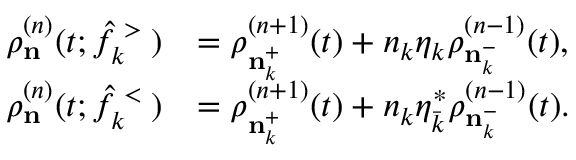<formula> <loc_0><loc_0><loc_500><loc_500>\begin{array} { r l } { \rho _ { n } ^ { ( n ) } ( t ; \hat { f } _ { k } ^ { > } ) } & { = \rho _ { { n } _ { k } ^ { + } } ^ { ( n + 1 ) } ( t ) + n _ { k } \eta _ { k } \rho _ { { n } _ { k } ^ { - } } ^ { ( n - 1 ) } ( t ) , } \\ { \rho _ { n } ^ { ( n ) } ( t ; \hat { f } _ { k } ^ { < } ) } & { = \rho _ { { n } _ { k } ^ { + } } ^ { ( n + 1 ) } ( t ) + n _ { k } \eta _ { \bar { k } } ^ { \ast } \rho _ { { n } _ { k } ^ { - } } ^ { ( n - 1 ) } ( t ) . } \end{array}</formula> 